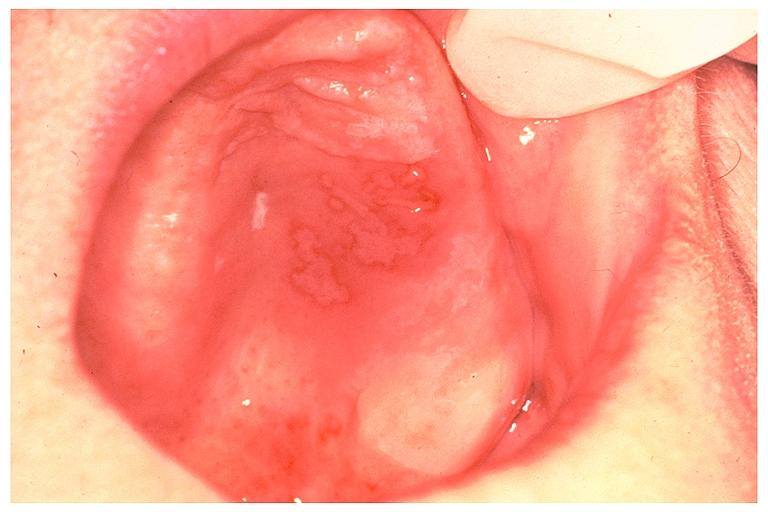where is this?
Answer the question using a single word or phrase. Oral 